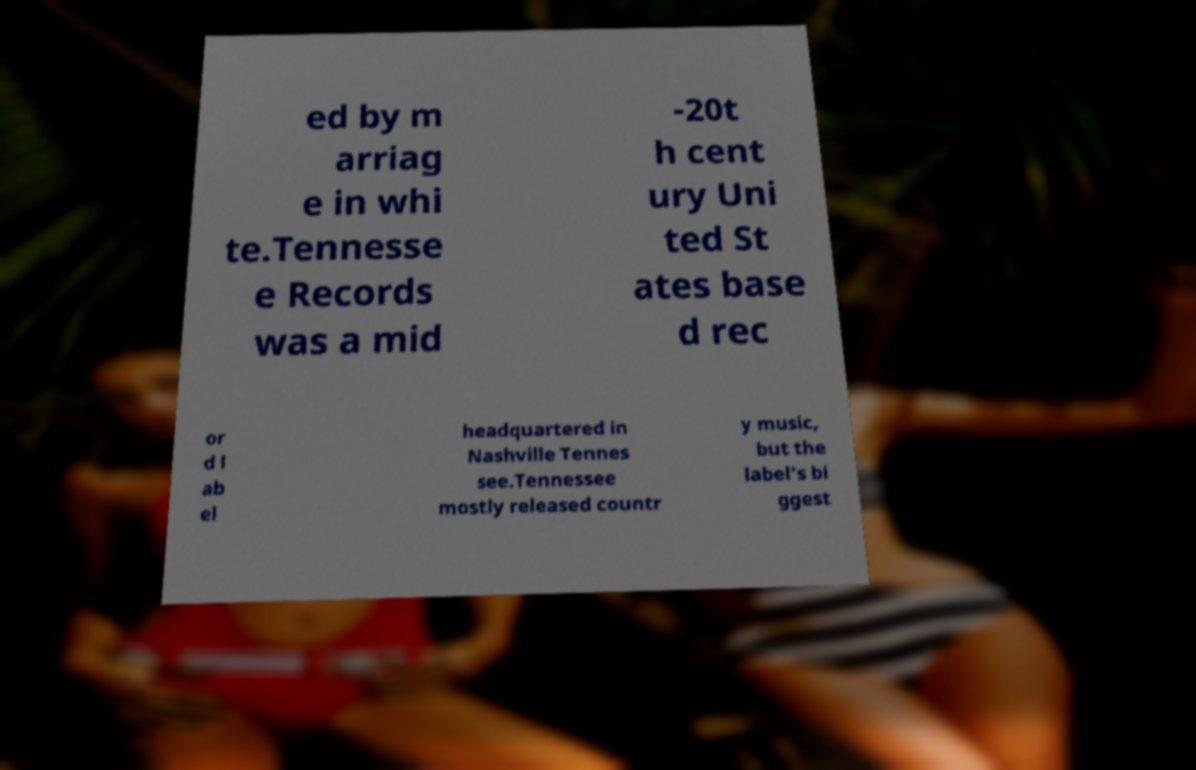Please read and relay the text visible in this image. What does it say? ed by m arriag e in whi te.Tennesse e Records was a mid -20t h cent ury Uni ted St ates base d rec or d l ab el headquartered in Nashville Tennes see.Tennessee mostly released countr y music, but the label's bi ggest 